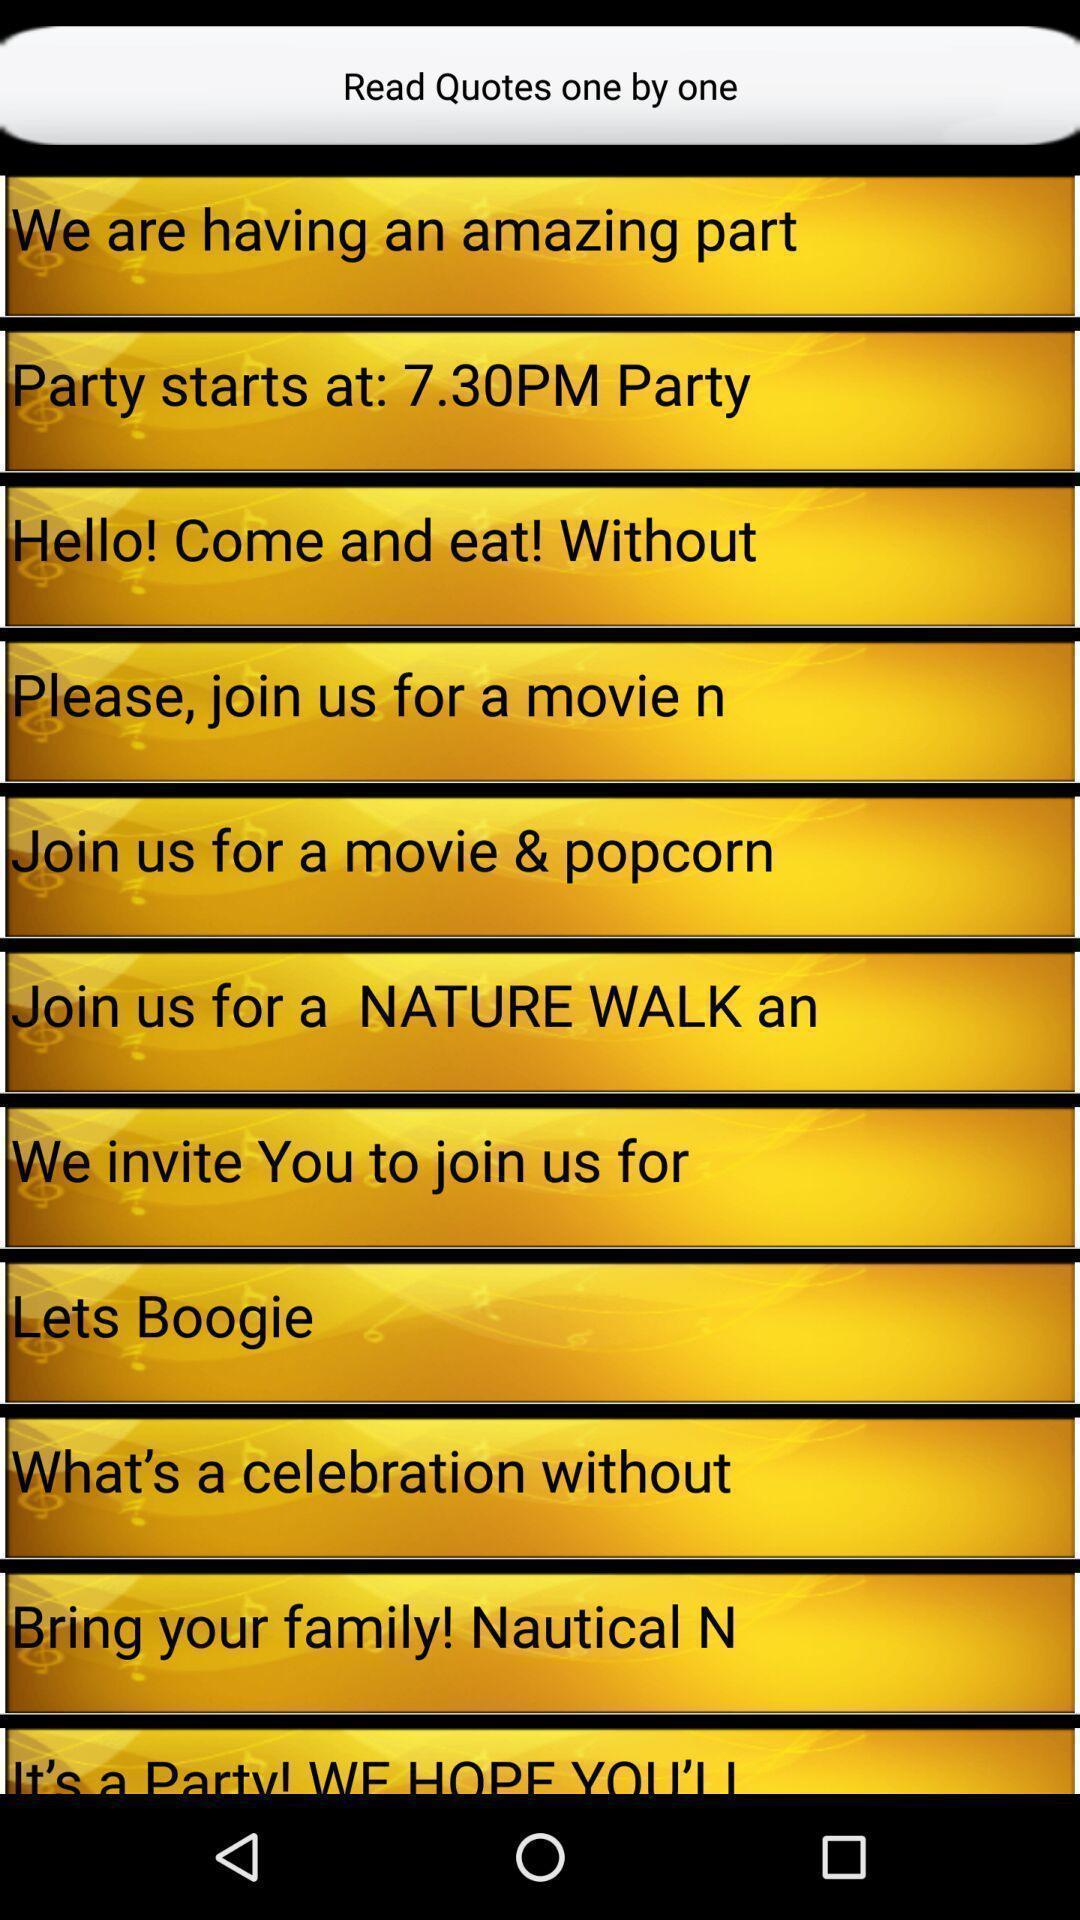Describe this image in words. Social app showing list of quotes. 